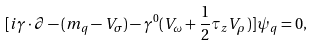<formula> <loc_0><loc_0><loc_500><loc_500>[ i \gamma \cdot \partial - ( m _ { q } - V _ { \sigma } ) - \gamma ^ { 0 } ( V _ { \omega } + \frac { 1 } { 2 } \tau _ { z } V _ { \rho } ) ] \psi _ { q } = 0 ,</formula> 